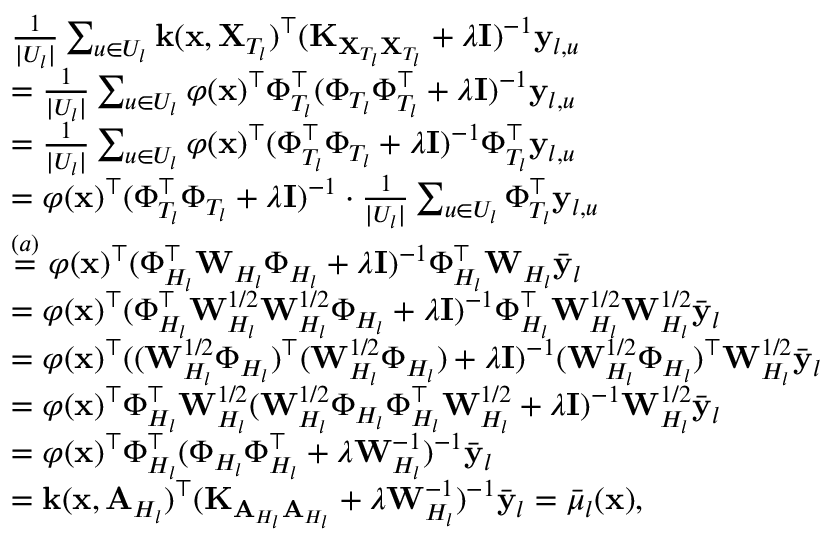Convert formula to latex. <formula><loc_0><loc_0><loc_500><loc_500>\begin{array} { r l } & { \frac { 1 } { | U _ { l } | } \sum _ { u \in U _ { l } } k ( x , X _ { T _ { l } } ) ^ { \top } ( K _ { X _ { T _ { l } } X _ { T _ { l } } } + \lambda I ) ^ { - 1 } y _ { l , u } } \\ & { = \frac { 1 } { | U _ { l } | } \sum _ { u \in U _ { l } } \varphi ( x ) ^ { \top } \Phi _ { T _ { l } } ^ { \top } ( \Phi _ { T _ { l } } \Phi _ { T _ { l } } ^ { \top } + \lambda I ) ^ { - 1 } y _ { l , u } } \\ & { = \frac { 1 } { | U _ { l } | } \sum _ { u \in U _ { l } } \varphi ( x ) ^ { \top } ( \Phi _ { T _ { l } } ^ { \top } \Phi _ { T _ { l } } + \lambda I ) ^ { - 1 } \Phi _ { T _ { l } } ^ { \top } y _ { l , u } } \\ & { = \varphi ( x ) ^ { \top } ( \Phi _ { T _ { l } } ^ { \top } \Phi _ { T _ { l } } + \lambda I ) ^ { - 1 } \cdot \frac { 1 } { | U _ { l } | } \sum _ { u \in U _ { l } } \Phi _ { T _ { l } } ^ { \top } y _ { l , u } } \\ & { \overset { ( a ) } { = } \varphi ( x ) ^ { \top } ( \Phi _ { H _ { l } } ^ { \top } W _ { H _ { l } } \Phi _ { H _ { l } } + \lambda I ) ^ { - 1 } \Phi _ { H _ { l } } ^ { \top } W _ { H _ { l } } \bar { y } _ { l } } \\ & { = \varphi ( x ) ^ { \top } ( \Phi _ { H _ { l } } ^ { \top } W _ { H _ { l } } ^ { 1 / 2 } W _ { H _ { l } } ^ { 1 / 2 } \Phi _ { H _ { l } } + \lambda I ) ^ { - 1 } \Phi _ { H _ { l } } ^ { \top } W _ { H _ { l } } ^ { 1 / 2 } W _ { H _ { l } } ^ { 1 / 2 } \bar { y } _ { l } } \\ & { = \varphi ( x ) ^ { \top } ( ( W _ { H _ { l } } ^ { 1 / 2 } \Phi _ { H _ { l } } ) ^ { \top } ( W _ { H _ { l } } ^ { 1 / 2 } \Phi _ { H _ { l } } ) + \lambda I ) ^ { - 1 } ( W _ { H _ { l } } ^ { 1 / 2 } \Phi _ { H _ { l } } ) ^ { \top } W _ { H _ { l } } ^ { 1 / 2 } \bar { y } _ { l } } \\ & { = \varphi ( x ) ^ { \top } \Phi _ { H _ { l } } ^ { \top } W _ { H _ { l } } ^ { 1 / 2 } ( W _ { H _ { l } } ^ { 1 / 2 } \Phi _ { H _ { l } } \Phi _ { H _ { l } } ^ { \top } W _ { H _ { l } } ^ { 1 / 2 } + \lambda I ) ^ { - 1 } W _ { H _ { l } } ^ { 1 / 2 } \bar { y } _ { l } } \\ & { = \varphi ( x ) ^ { \top } \Phi _ { H _ { l } } ^ { \top } ( \Phi _ { H _ { l } } \Phi _ { H _ { l } } ^ { \top } + \lambda W _ { H _ { l } } ^ { - 1 } ) ^ { - 1 } \bar { y } _ { l } } \\ & { = k ( x , A _ { H _ { l } } ) ^ { \top } ( K _ { A _ { H _ { l } } A _ { H _ { l } } } + \lambda W _ { H _ { l } } ^ { - 1 } ) ^ { - 1 } \bar { y } _ { l } = \bar { \mu } _ { l } ( x ) , } \end{array}</formula> 